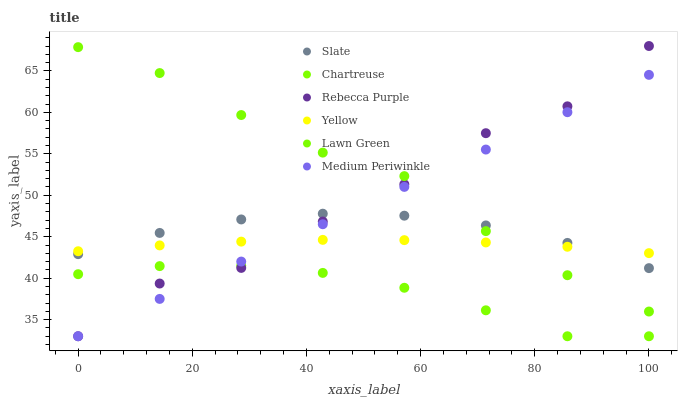Does Chartreuse have the minimum area under the curve?
Answer yes or no. Yes. Does Lawn Green have the maximum area under the curve?
Answer yes or no. Yes. Does Slate have the minimum area under the curve?
Answer yes or no. No. Does Slate have the maximum area under the curve?
Answer yes or no. No. Is Medium Periwinkle the smoothest?
Answer yes or no. Yes. Is Rebecca Purple the roughest?
Answer yes or no. Yes. Is Slate the smoothest?
Answer yes or no. No. Is Slate the roughest?
Answer yes or no. No. Does Medium Periwinkle have the lowest value?
Answer yes or no. Yes. Does Slate have the lowest value?
Answer yes or no. No. Does Rebecca Purple have the highest value?
Answer yes or no. Yes. Does Slate have the highest value?
Answer yes or no. No. Is Chartreuse less than Slate?
Answer yes or no. Yes. Is Lawn Green greater than Chartreuse?
Answer yes or no. Yes. Does Slate intersect Yellow?
Answer yes or no. Yes. Is Slate less than Yellow?
Answer yes or no. No. Is Slate greater than Yellow?
Answer yes or no. No. Does Chartreuse intersect Slate?
Answer yes or no. No. 